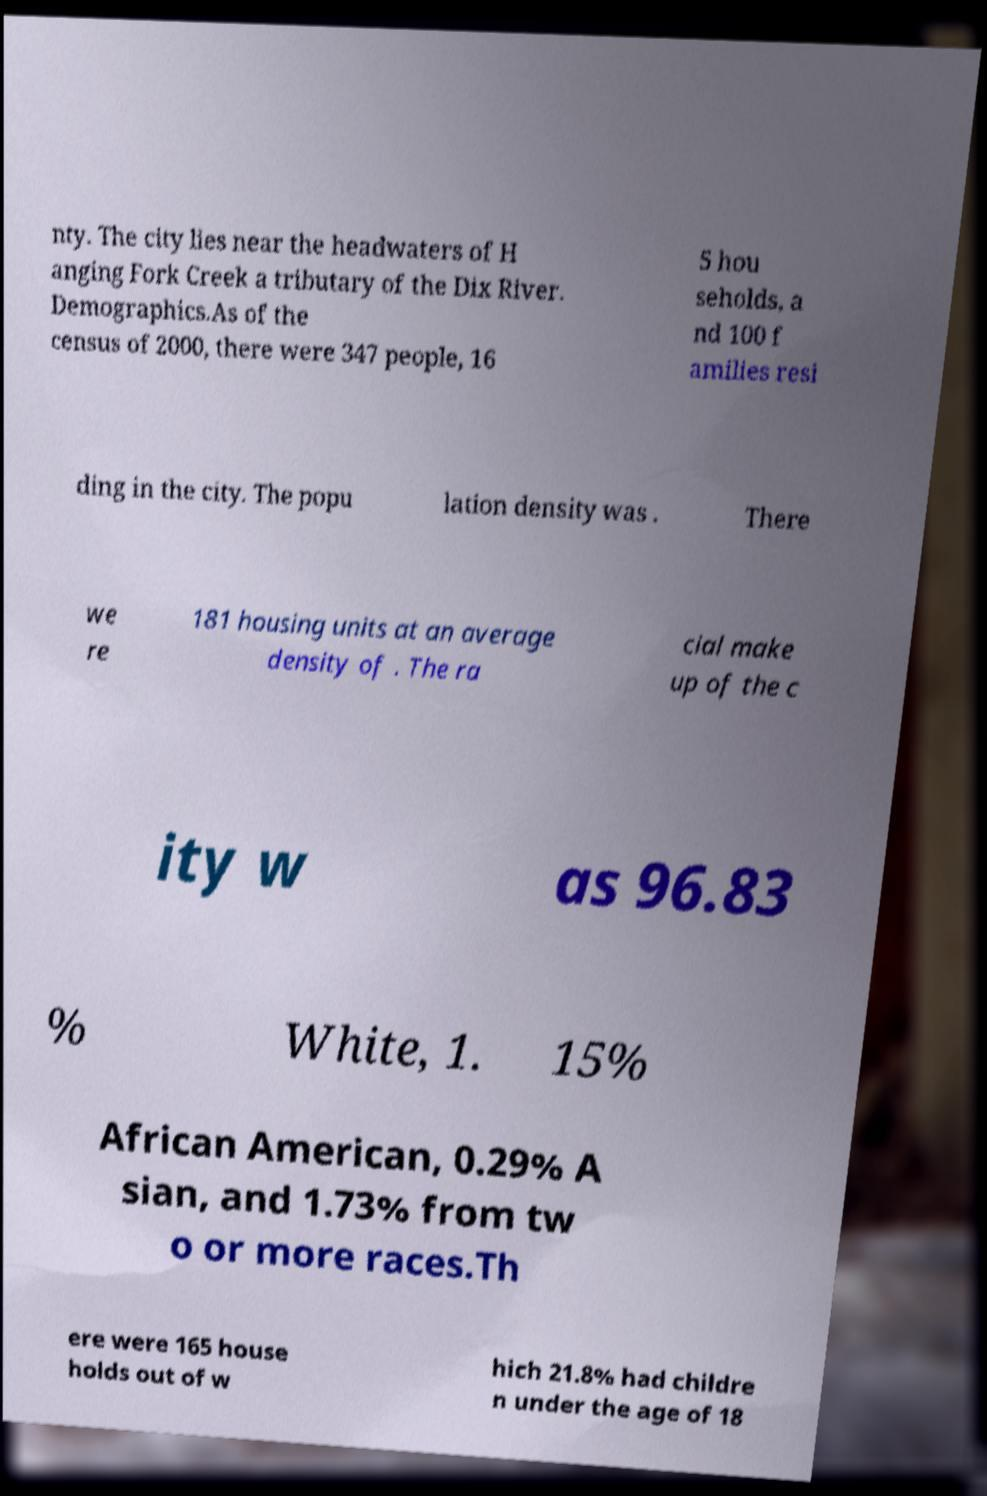I need the written content from this picture converted into text. Can you do that? nty. The city lies near the headwaters of H anging Fork Creek a tributary of the Dix River. Demographics.As of the census of 2000, there were 347 people, 16 5 hou seholds, a nd 100 f amilies resi ding in the city. The popu lation density was . There we re 181 housing units at an average density of . The ra cial make up of the c ity w as 96.83 % White, 1. 15% African American, 0.29% A sian, and 1.73% from tw o or more races.Th ere were 165 house holds out of w hich 21.8% had childre n under the age of 18 